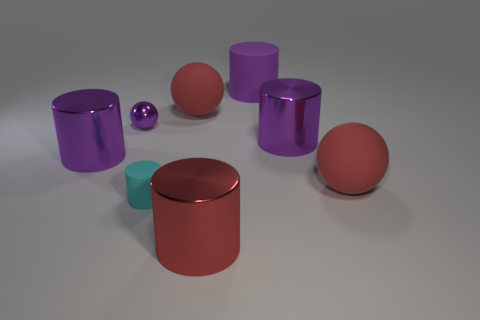Subtract all large red balls. How many balls are left? 1 Add 2 large red matte balls. How many large red matte balls exist? 4 Add 1 big shiny things. How many objects exist? 9 Subtract all cyan cylinders. How many cylinders are left? 4 Subtract 0 cyan blocks. How many objects are left? 8 Subtract all spheres. How many objects are left? 5 Subtract 3 cylinders. How many cylinders are left? 2 Subtract all gray spheres. Subtract all cyan blocks. How many spheres are left? 3 Subtract all blue blocks. How many red balls are left? 2 Subtract all purple spheres. Subtract all small red matte spheres. How many objects are left? 7 